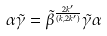Convert formula to latex. <formula><loc_0><loc_0><loc_500><loc_500>\alpha \tilde { \gamma } = \tilde { \beta } ^ { \frac { 2 k ^ { \prime } } { ( k , 2 k ^ { \prime } ) } } \tilde { \gamma } \alpha</formula> 